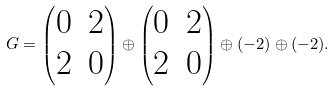<formula> <loc_0><loc_0><loc_500><loc_500>G = \left ( \begin{matrix} 0 & 2 \\ 2 & 0 \end{matrix} \right ) \oplus \left ( \begin{matrix} 0 & 2 \\ 2 & 0 \end{matrix} \right ) \oplus ( - 2 ) \oplus ( - 2 ) .</formula> 